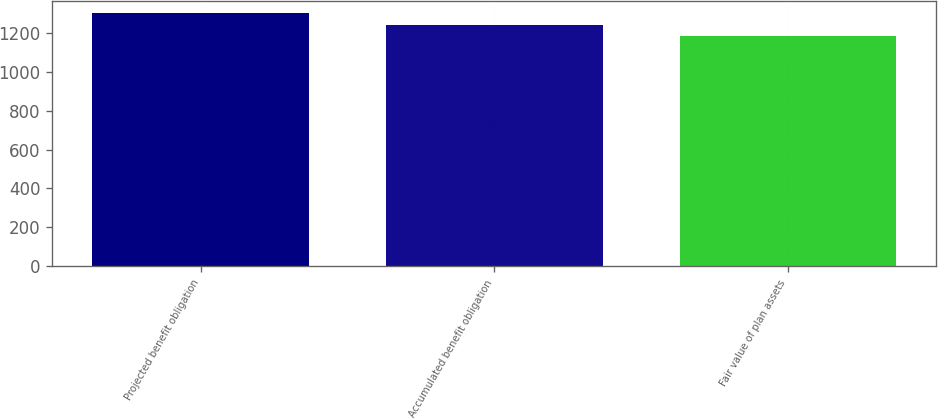Convert chart to OTSL. <chart><loc_0><loc_0><loc_500><loc_500><bar_chart><fcel>Projected benefit obligation<fcel>Accumulated benefit obligation<fcel>Fair value of plan assets<nl><fcel>1299<fcel>1239<fcel>1182<nl></chart> 